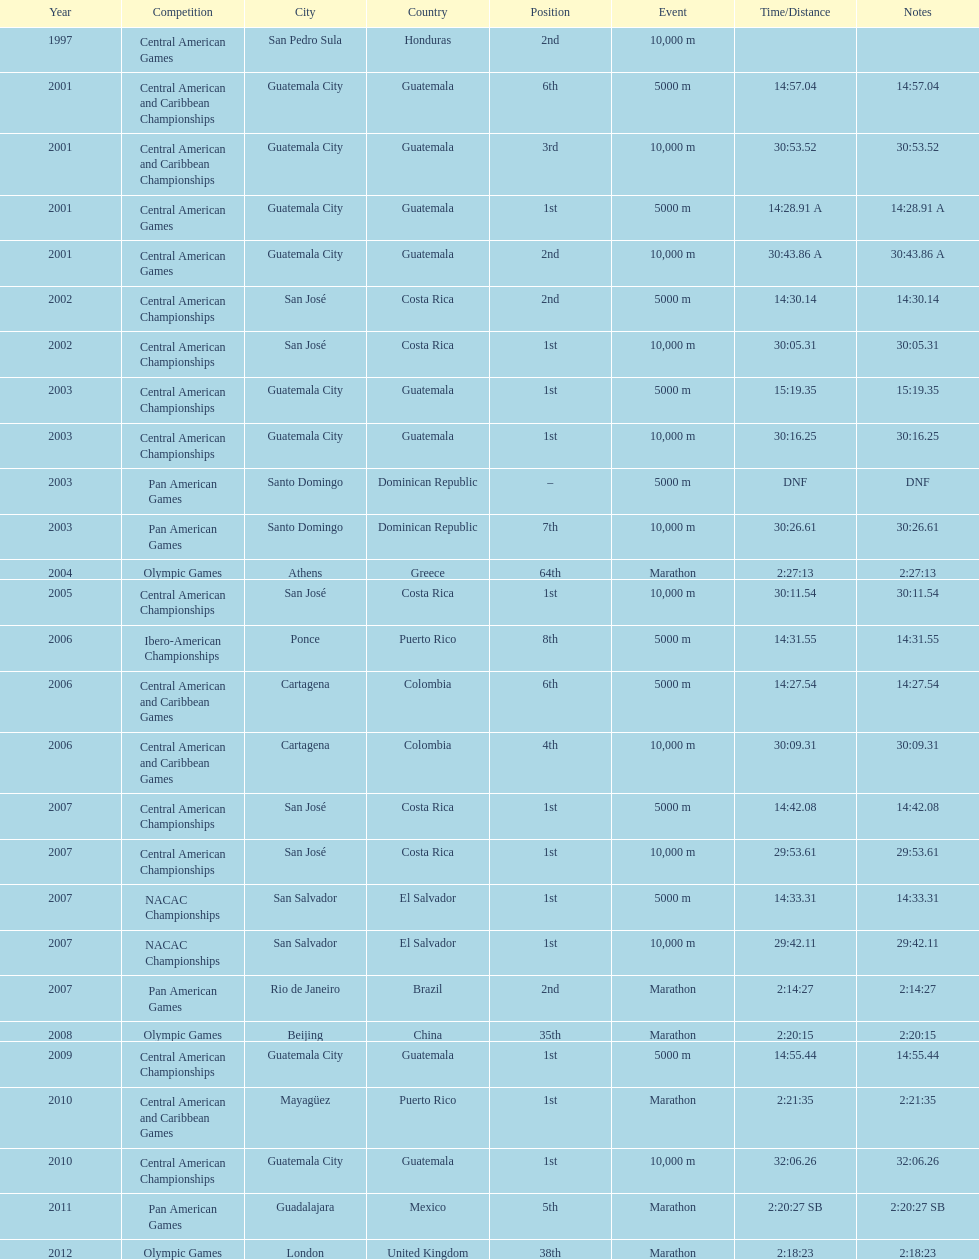Give me the full table as a dictionary. {'header': ['Year', 'Competition', 'City', 'Country', 'Position', 'Event', 'Time/Distance', 'Notes'], 'rows': [['1997', 'Central American Games', 'San Pedro Sula', 'Honduras', '2nd', '10,000 m', '', ''], ['2001', 'Central American and Caribbean Championships', 'Guatemala City', 'Guatemala', '6th', '5000 m', '14:57.04', '14:57.04'], ['2001', 'Central American and Caribbean Championships', 'Guatemala City', 'Guatemala', '3rd', '10,000 m', '30:53.52', '30:53.52'], ['2001', 'Central American Games', 'Guatemala City', 'Guatemala', '1st', '5000 m', '14:28.91 A', '14:28.91 A'], ['2001', 'Central American Games', 'Guatemala City', 'Guatemala', '2nd', '10,000 m', '30:43.86 A', '30:43.86 A'], ['2002', 'Central American Championships', 'San José', 'Costa Rica', '2nd', '5000 m', '14:30.14', '14:30.14'], ['2002', 'Central American Championships', 'San José', 'Costa Rica', '1st', '10,000 m', '30:05.31', '30:05.31'], ['2003', 'Central American Championships', 'Guatemala City', 'Guatemala', '1st', '5000 m', '15:19.35', '15:19.35'], ['2003', 'Central American Championships', 'Guatemala City', 'Guatemala', '1st', '10,000 m', '30:16.25', '30:16.25'], ['2003', 'Pan American Games', 'Santo Domingo', 'Dominican Republic', '–', '5000 m', 'DNF', 'DNF'], ['2003', 'Pan American Games', 'Santo Domingo', 'Dominican Republic', '7th', '10,000 m', '30:26.61', '30:26.61'], ['2004', 'Olympic Games', 'Athens', 'Greece', '64th', 'Marathon', '2:27:13', '2:27:13'], ['2005', 'Central American Championships', 'San José', 'Costa Rica', '1st', '10,000 m', '30:11.54', '30:11.54'], ['2006', 'Ibero-American Championships', 'Ponce', 'Puerto Rico', '8th', '5000 m', '14:31.55', '14:31.55'], ['2006', 'Central American and Caribbean Games', 'Cartagena', 'Colombia', '6th', '5000 m', '14:27.54', '14:27.54'], ['2006', 'Central American and Caribbean Games', 'Cartagena', 'Colombia', '4th', '10,000 m', '30:09.31', '30:09.31'], ['2007', 'Central American Championships', 'San José', 'Costa Rica', '1st', '5000 m', '14:42.08', '14:42.08'], ['2007', 'Central American Championships', 'San José', 'Costa Rica', '1st', '10,000 m', '29:53.61', '29:53.61'], ['2007', 'NACAC Championships', 'San Salvador', 'El Salvador', '1st', '5000 m', '14:33.31', '14:33.31'], ['2007', 'NACAC Championships', 'San Salvador', 'El Salvador', '1st', '10,000 m', '29:42.11', '29:42.11'], ['2007', 'Pan American Games', 'Rio de Janeiro', 'Brazil', '2nd', 'Marathon', '2:14:27', '2:14:27'], ['2008', 'Olympic Games', 'Beijing', 'China', '35th', 'Marathon', '2:20:15', '2:20:15'], ['2009', 'Central American Championships', 'Guatemala City', 'Guatemala', '1st', '5000 m', '14:55.44', '14:55.44'], ['2010', 'Central American and Caribbean Games', 'Mayagüez', 'Puerto Rico', '1st', 'Marathon', '2:21:35', '2:21:35'], ['2010', 'Central American Championships', 'Guatemala City', 'Guatemala', '1st', '10,000 m', '32:06.26', '32:06.26'], ['2011', 'Pan American Games', 'Guadalajara', 'Mexico', '5th', 'Marathon', '2:20:27 SB', '2:20:27 SB'], ['2012', 'Olympic Games', 'London', 'United Kingdom', '38th', 'Marathon', '2:18:23', '2:18:23']]} Tell me the number of times they competed in guatamala. 5. 